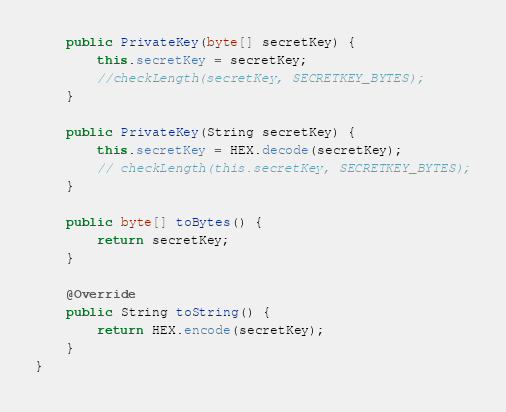<code> <loc_0><loc_0><loc_500><loc_500><_Java_>    public PrivateKey(byte[] secretKey) {
        this.secretKey = secretKey;
        //checkLength(secretKey, SECRETKEY_BYTES);
    }

    public PrivateKey(String secretKey) {
        this.secretKey = HEX.decode(secretKey);
        // checkLength(this.secretKey, SECRETKEY_BYTES);
    }

    public byte[] toBytes() {
        return secretKey;
    }

    @Override
    public String toString() {
        return HEX.encode(secretKey);
    }
}
</code> 